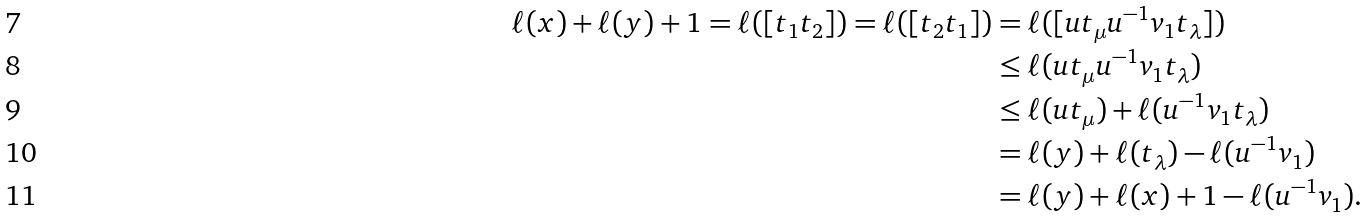Convert formula to latex. <formula><loc_0><loc_0><loc_500><loc_500>\ell ( x ) + \ell ( y ) + 1 = \ell ( [ t _ { 1 } t _ { 2 } ] ) = \ell ( [ t _ { 2 } t _ { 1 } ] ) & = \ell ( [ u t _ { \mu } u ^ { - 1 } v _ { 1 } t _ { \lambda } ] ) \\ & \leq \ell ( u t _ { \mu } u ^ { - 1 } v _ { 1 } t _ { \lambda } ) \\ & \leq \ell ( u t _ { \mu } ) + \ell ( u ^ { - 1 } v _ { 1 } t _ { \lambda } ) \\ & = \ell ( y ) + \ell ( t _ { \lambda } ) - \ell ( u ^ { - 1 } v _ { 1 } ) \\ & = \ell ( y ) + \ell ( x ) + 1 - \ell ( u ^ { - 1 } v _ { 1 } ) .</formula> 